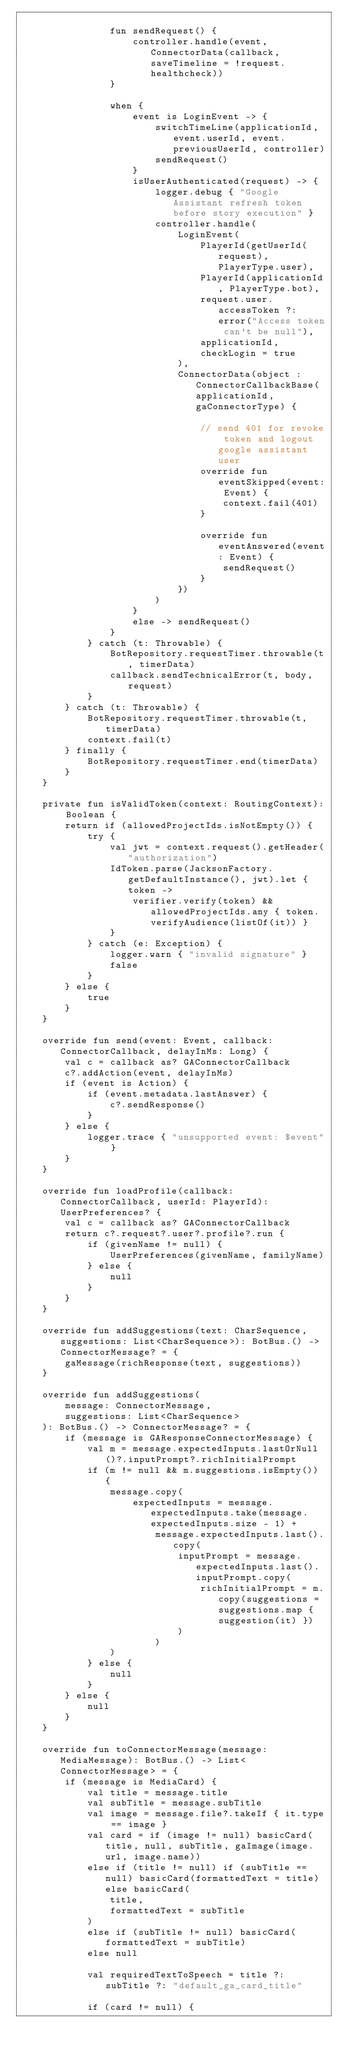Convert code to text. <code><loc_0><loc_0><loc_500><loc_500><_Kotlin_>
                fun sendRequest() {
                    controller.handle(event, ConnectorData(callback, saveTimeline = !request.healthcheck))
                }

                when {
                    event is LoginEvent -> {
                        switchTimeLine(applicationId, event.userId, event.previousUserId, controller)
                        sendRequest()
                    }
                    isUserAuthenticated(request) -> {
                        logger.debug { "Google Assistant refresh token before story execution" }
                        controller.handle(
                            LoginEvent(
                                PlayerId(getUserId(request), PlayerType.user),
                                PlayerId(applicationId, PlayerType.bot),
                                request.user.accessToken ?: error("Access token can't be null"),
                                applicationId,
                                checkLogin = true
                            ),
                            ConnectorData(object : ConnectorCallbackBase(applicationId, gaConnectorType) {

                                // send 401 for revoke token and logout google assistant user
                                override fun eventSkipped(event: Event) {
                                    context.fail(401)
                                }

                                override fun eventAnswered(event: Event) {
                                    sendRequest()
                                }
                            })
                        )
                    }
                    else -> sendRequest()
                }
            } catch (t: Throwable) {
                BotRepository.requestTimer.throwable(t, timerData)
                callback.sendTechnicalError(t, body, request)
            }
        } catch (t: Throwable) {
            BotRepository.requestTimer.throwable(t, timerData)
            context.fail(t)
        } finally {
            BotRepository.requestTimer.end(timerData)
        }
    }

    private fun isValidToken(context: RoutingContext): Boolean {
        return if (allowedProjectIds.isNotEmpty()) {
            try {
                val jwt = context.request().getHeader("authorization")
                IdToken.parse(JacksonFactory.getDefaultInstance(), jwt).let { token ->
                    verifier.verify(token) && allowedProjectIds.any { token.verifyAudience(listOf(it)) }
                }
            } catch (e: Exception) {
                logger.warn { "invalid signature" }
                false
            }
        } else {
            true
        }
    }

    override fun send(event: Event, callback: ConnectorCallback, delayInMs: Long) {
        val c = callback as? GAConnectorCallback
        c?.addAction(event, delayInMs)
        if (event is Action) {
            if (event.metadata.lastAnswer) {
                c?.sendResponse()
            }
        } else {
            logger.trace { "unsupported event: $event" }
        }
    }

    override fun loadProfile(callback: ConnectorCallback, userId: PlayerId): UserPreferences? {
        val c = callback as? GAConnectorCallback
        return c?.request?.user?.profile?.run {
            if (givenName != null) {
                UserPreferences(givenName, familyName)
            } else {
                null
            }
        }
    }

    override fun addSuggestions(text: CharSequence, suggestions: List<CharSequence>): BotBus.() -> ConnectorMessage? = {
        gaMessage(richResponse(text, suggestions))
    }

    override fun addSuggestions(
        message: ConnectorMessage,
        suggestions: List<CharSequence>
    ): BotBus.() -> ConnectorMessage? = {
        if (message is GAResponseConnectorMessage) {
            val m = message.expectedInputs.lastOrNull()?.inputPrompt?.richInitialPrompt
            if (m != null && m.suggestions.isEmpty()) {
                message.copy(
                    expectedInputs = message.expectedInputs.take(message.expectedInputs.size - 1) +
                        message.expectedInputs.last().copy(
                            inputPrompt = message.expectedInputs.last().inputPrompt.copy(
                                richInitialPrompt = m.copy(suggestions = suggestions.map { suggestion(it) })
                            )
                        )
                )
            } else {
                null
            }
        } else {
            null
        }
    }

    override fun toConnectorMessage(message: MediaMessage): BotBus.() -> List<ConnectorMessage> = {
        if (message is MediaCard) {
            val title = message.title
            val subTitle = message.subTitle
            val image = message.file?.takeIf { it.type == image }
            val card = if (image != null) basicCard(title, null, subTitle, gaImage(image.url, image.name))
            else if (title != null) if (subTitle == null) basicCard(formattedText = title) else basicCard(
                title,
                formattedText = subTitle
            )
            else if (subTitle != null) basicCard(formattedText = subTitle)
            else null

            val requiredTextToSpeech = title ?: subTitle ?: "default_ga_card_title"

            if (card != null) {</code> 